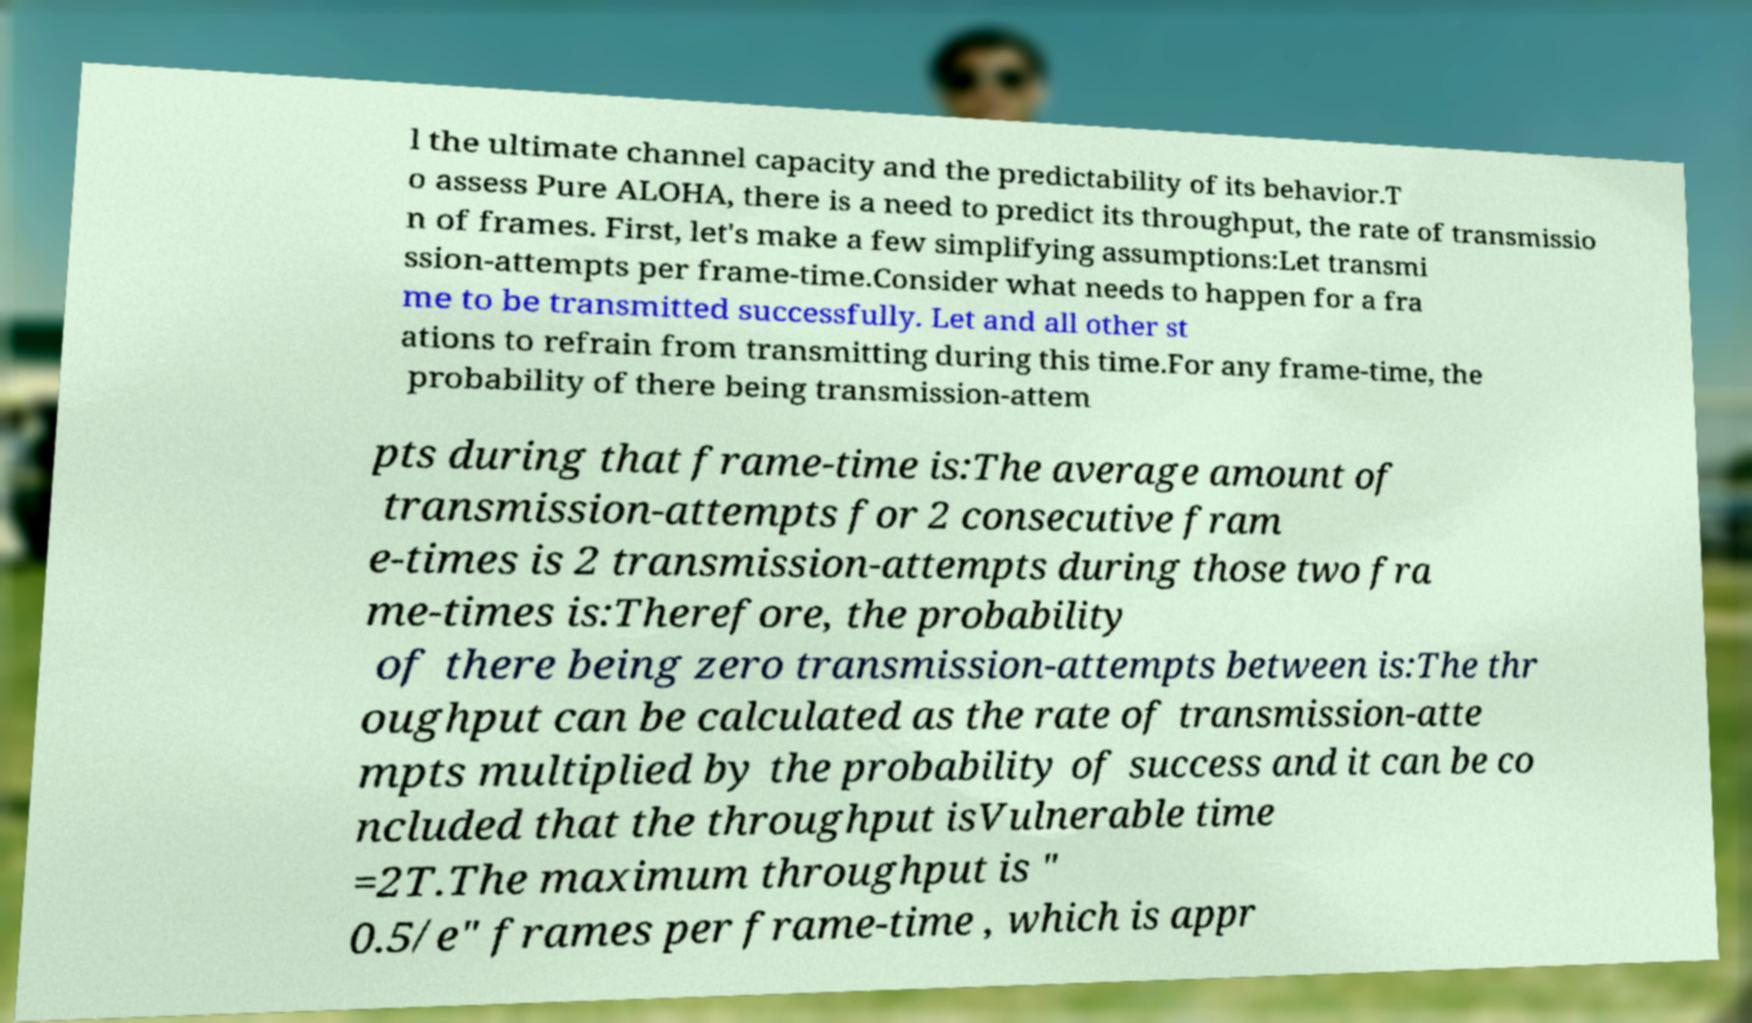For documentation purposes, I need the text within this image transcribed. Could you provide that? l the ultimate channel capacity and the predictability of its behavior.T o assess Pure ALOHA, there is a need to predict its throughput, the rate of transmissio n of frames. First, let's make a few simplifying assumptions:Let transmi ssion-attempts per frame-time.Consider what needs to happen for a fra me to be transmitted successfully. Let and all other st ations to refrain from transmitting during this time.For any frame-time, the probability of there being transmission-attem pts during that frame-time is:The average amount of transmission-attempts for 2 consecutive fram e-times is 2 transmission-attempts during those two fra me-times is:Therefore, the probability of there being zero transmission-attempts between is:The thr oughput can be calculated as the rate of transmission-atte mpts multiplied by the probability of success and it can be co ncluded that the throughput isVulnerable time =2T.The maximum throughput is " 0.5/e" frames per frame-time , which is appr 